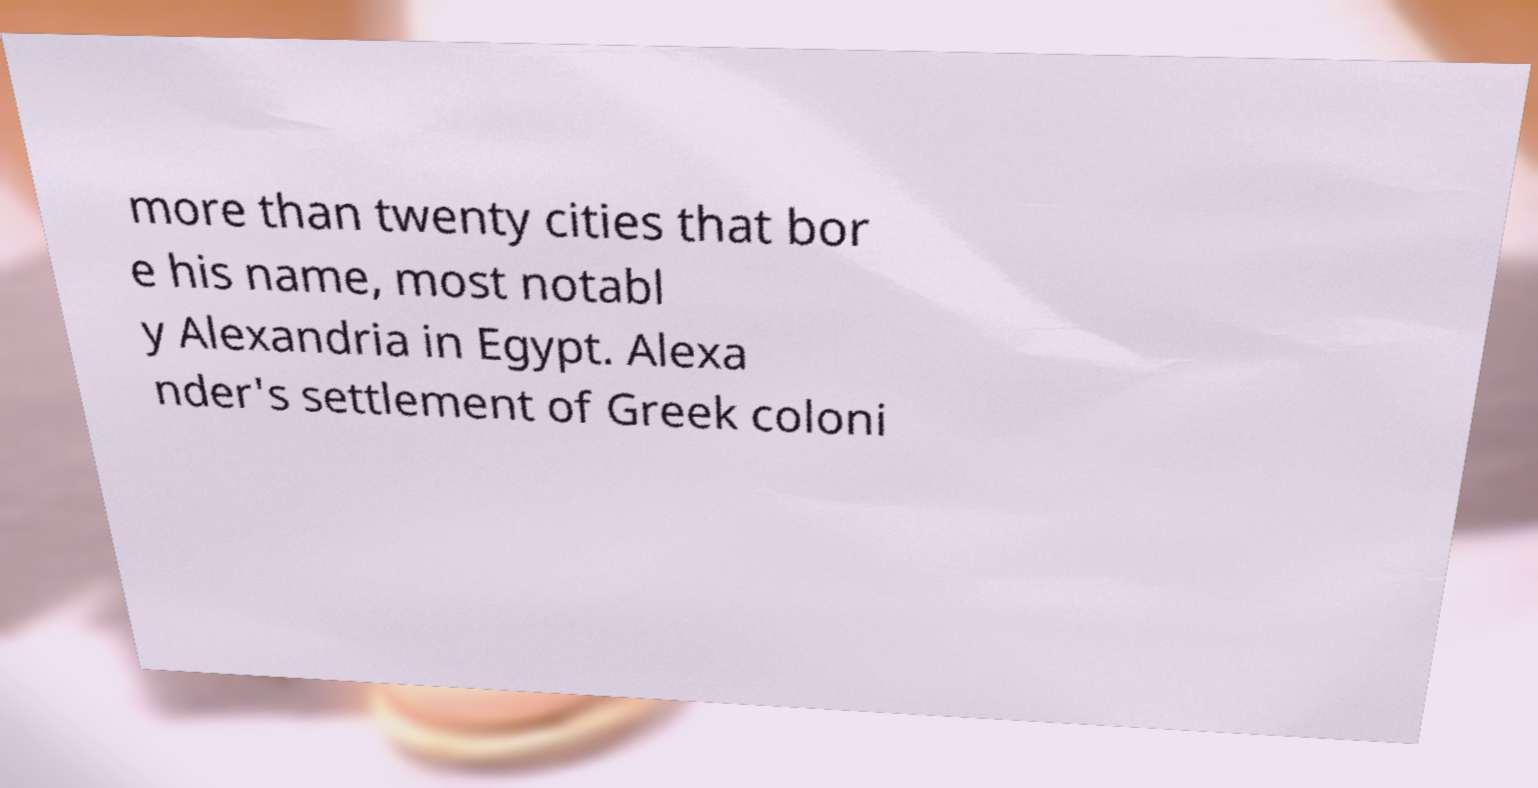Please read and relay the text visible in this image. What does it say? more than twenty cities that bor e his name, most notabl y Alexandria in Egypt. Alexa nder's settlement of Greek coloni 